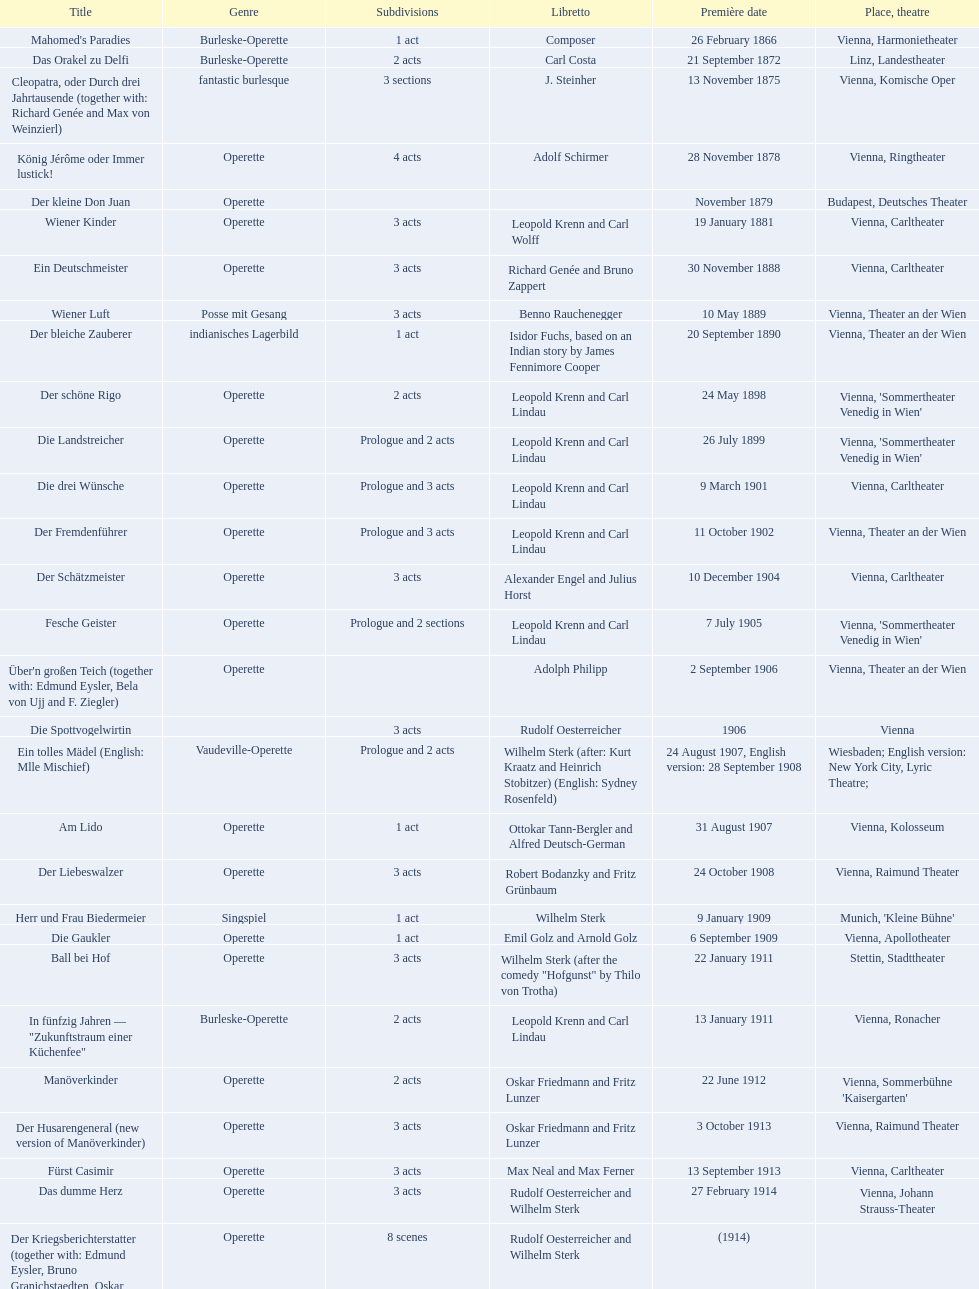In this chart, which genre is predominantly featured? Operette. 